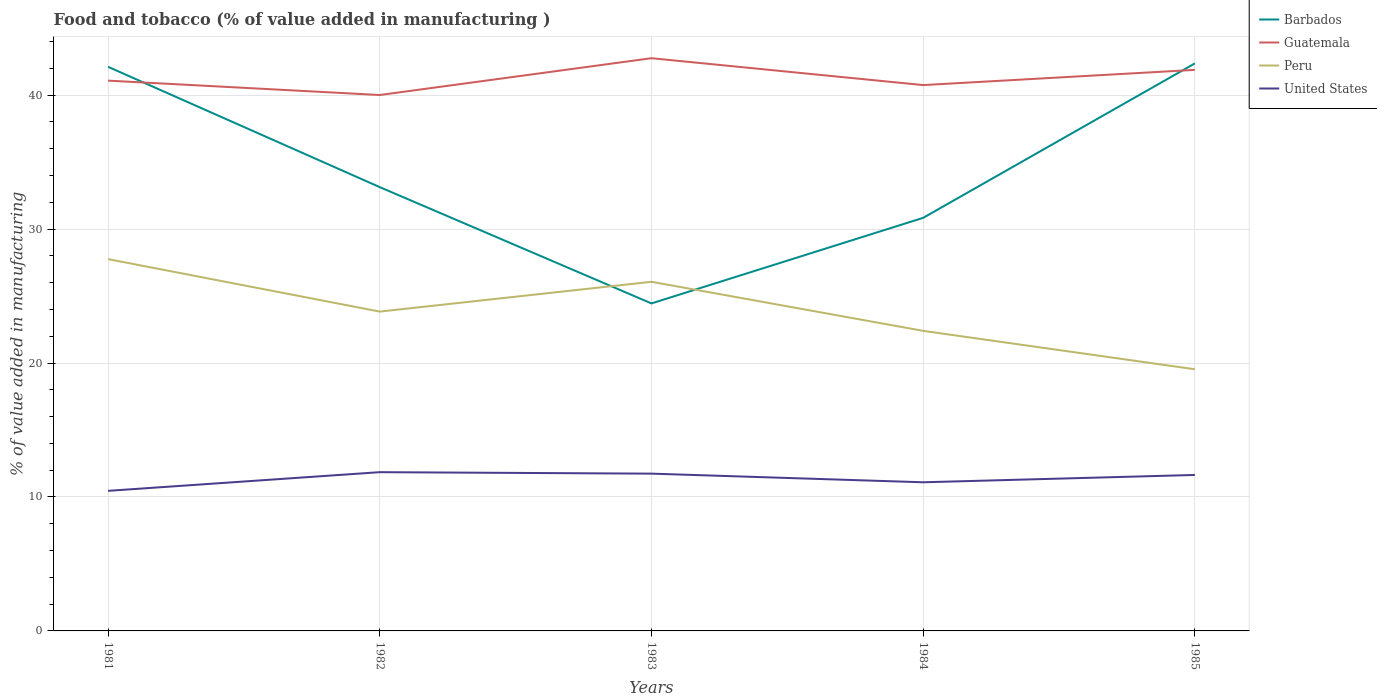Does the line corresponding to Peru intersect with the line corresponding to Barbados?
Provide a succinct answer. Yes. Across all years, what is the maximum value added in manufacturing food and tobacco in United States?
Your answer should be compact. 10.46. What is the total value added in manufacturing food and tobacco in Barbados in the graph?
Give a very brief answer. 8.98. What is the difference between the highest and the second highest value added in manufacturing food and tobacco in Barbados?
Your answer should be compact. 17.92. What is the difference between the highest and the lowest value added in manufacturing food and tobacco in Guatemala?
Make the answer very short. 2. Is the value added in manufacturing food and tobacco in Peru strictly greater than the value added in manufacturing food and tobacco in Guatemala over the years?
Your answer should be compact. Yes. How many lines are there?
Offer a terse response. 4. How many years are there in the graph?
Make the answer very short. 5. Does the graph contain grids?
Your response must be concise. Yes. How many legend labels are there?
Keep it short and to the point. 4. What is the title of the graph?
Offer a terse response. Food and tobacco (% of value added in manufacturing ). What is the label or title of the X-axis?
Your answer should be compact. Years. What is the label or title of the Y-axis?
Make the answer very short. % of value added in manufacturing. What is the % of value added in manufacturing in Barbados in 1981?
Ensure brevity in your answer.  42.12. What is the % of value added in manufacturing of Guatemala in 1981?
Ensure brevity in your answer.  41.09. What is the % of value added in manufacturing in Peru in 1981?
Your answer should be compact. 27.76. What is the % of value added in manufacturing in United States in 1981?
Your answer should be very brief. 10.46. What is the % of value added in manufacturing of Barbados in 1982?
Keep it short and to the point. 33.13. What is the % of value added in manufacturing of Guatemala in 1982?
Your answer should be compact. 40.01. What is the % of value added in manufacturing in Peru in 1982?
Provide a short and direct response. 23.84. What is the % of value added in manufacturing of United States in 1982?
Offer a terse response. 11.85. What is the % of value added in manufacturing of Barbados in 1983?
Ensure brevity in your answer.  24.45. What is the % of value added in manufacturing in Guatemala in 1983?
Provide a short and direct response. 42.76. What is the % of value added in manufacturing of Peru in 1983?
Provide a short and direct response. 26.07. What is the % of value added in manufacturing of United States in 1983?
Make the answer very short. 11.74. What is the % of value added in manufacturing of Barbados in 1984?
Offer a terse response. 30.84. What is the % of value added in manufacturing of Guatemala in 1984?
Make the answer very short. 40.75. What is the % of value added in manufacturing in Peru in 1984?
Your answer should be compact. 22.4. What is the % of value added in manufacturing in United States in 1984?
Provide a succinct answer. 11.1. What is the % of value added in manufacturing of Barbados in 1985?
Provide a succinct answer. 42.37. What is the % of value added in manufacturing in Guatemala in 1985?
Offer a terse response. 41.89. What is the % of value added in manufacturing of Peru in 1985?
Provide a short and direct response. 19.54. What is the % of value added in manufacturing of United States in 1985?
Your answer should be very brief. 11.64. Across all years, what is the maximum % of value added in manufacturing of Barbados?
Keep it short and to the point. 42.37. Across all years, what is the maximum % of value added in manufacturing in Guatemala?
Make the answer very short. 42.76. Across all years, what is the maximum % of value added in manufacturing of Peru?
Keep it short and to the point. 27.76. Across all years, what is the maximum % of value added in manufacturing of United States?
Your answer should be very brief. 11.85. Across all years, what is the minimum % of value added in manufacturing of Barbados?
Ensure brevity in your answer.  24.45. Across all years, what is the minimum % of value added in manufacturing of Guatemala?
Ensure brevity in your answer.  40.01. Across all years, what is the minimum % of value added in manufacturing in Peru?
Give a very brief answer. 19.54. Across all years, what is the minimum % of value added in manufacturing of United States?
Keep it short and to the point. 10.46. What is the total % of value added in manufacturing in Barbados in the graph?
Make the answer very short. 172.91. What is the total % of value added in manufacturing in Guatemala in the graph?
Your answer should be very brief. 206.5. What is the total % of value added in manufacturing of Peru in the graph?
Offer a very short reply. 119.6. What is the total % of value added in manufacturing in United States in the graph?
Offer a very short reply. 56.79. What is the difference between the % of value added in manufacturing of Barbados in 1981 and that in 1982?
Your answer should be compact. 8.98. What is the difference between the % of value added in manufacturing in Guatemala in 1981 and that in 1982?
Keep it short and to the point. 1.07. What is the difference between the % of value added in manufacturing of Peru in 1981 and that in 1982?
Provide a short and direct response. 3.92. What is the difference between the % of value added in manufacturing of United States in 1981 and that in 1982?
Offer a terse response. -1.39. What is the difference between the % of value added in manufacturing of Barbados in 1981 and that in 1983?
Make the answer very short. 17.67. What is the difference between the % of value added in manufacturing in Guatemala in 1981 and that in 1983?
Give a very brief answer. -1.67. What is the difference between the % of value added in manufacturing of Peru in 1981 and that in 1983?
Offer a very short reply. 1.69. What is the difference between the % of value added in manufacturing in United States in 1981 and that in 1983?
Keep it short and to the point. -1.28. What is the difference between the % of value added in manufacturing in Barbados in 1981 and that in 1984?
Keep it short and to the point. 11.28. What is the difference between the % of value added in manufacturing in Guatemala in 1981 and that in 1984?
Provide a short and direct response. 0.33. What is the difference between the % of value added in manufacturing in Peru in 1981 and that in 1984?
Make the answer very short. 5.36. What is the difference between the % of value added in manufacturing in United States in 1981 and that in 1984?
Provide a succinct answer. -0.64. What is the difference between the % of value added in manufacturing in Barbados in 1981 and that in 1985?
Offer a terse response. -0.25. What is the difference between the % of value added in manufacturing in Guatemala in 1981 and that in 1985?
Provide a succinct answer. -0.8. What is the difference between the % of value added in manufacturing in Peru in 1981 and that in 1985?
Your answer should be very brief. 8.22. What is the difference between the % of value added in manufacturing in United States in 1981 and that in 1985?
Provide a short and direct response. -1.19. What is the difference between the % of value added in manufacturing in Barbados in 1982 and that in 1983?
Make the answer very short. 8.68. What is the difference between the % of value added in manufacturing in Guatemala in 1982 and that in 1983?
Your response must be concise. -2.75. What is the difference between the % of value added in manufacturing of Peru in 1982 and that in 1983?
Give a very brief answer. -2.22. What is the difference between the % of value added in manufacturing of United States in 1982 and that in 1983?
Provide a short and direct response. 0.11. What is the difference between the % of value added in manufacturing in Barbados in 1982 and that in 1984?
Your answer should be very brief. 2.29. What is the difference between the % of value added in manufacturing in Guatemala in 1982 and that in 1984?
Your response must be concise. -0.74. What is the difference between the % of value added in manufacturing of Peru in 1982 and that in 1984?
Ensure brevity in your answer.  1.44. What is the difference between the % of value added in manufacturing in United States in 1982 and that in 1984?
Provide a short and direct response. 0.75. What is the difference between the % of value added in manufacturing of Barbados in 1982 and that in 1985?
Your answer should be compact. -9.24. What is the difference between the % of value added in manufacturing in Guatemala in 1982 and that in 1985?
Your response must be concise. -1.88. What is the difference between the % of value added in manufacturing of Peru in 1982 and that in 1985?
Keep it short and to the point. 4.3. What is the difference between the % of value added in manufacturing of United States in 1982 and that in 1985?
Your response must be concise. 0.21. What is the difference between the % of value added in manufacturing in Barbados in 1983 and that in 1984?
Your response must be concise. -6.39. What is the difference between the % of value added in manufacturing of Guatemala in 1983 and that in 1984?
Give a very brief answer. 2.01. What is the difference between the % of value added in manufacturing in Peru in 1983 and that in 1984?
Offer a terse response. 3.66. What is the difference between the % of value added in manufacturing in United States in 1983 and that in 1984?
Make the answer very short. 0.65. What is the difference between the % of value added in manufacturing of Barbados in 1983 and that in 1985?
Give a very brief answer. -17.92. What is the difference between the % of value added in manufacturing of Guatemala in 1983 and that in 1985?
Provide a short and direct response. 0.87. What is the difference between the % of value added in manufacturing in Peru in 1983 and that in 1985?
Your response must be concise. 6.53. What is the difference between the % of value added in manufacturing in United States in 1983 and that in 1985?
Provide a short and direct response. 0.1. What is the difference between the % of value added in manufacturing in Barbados in 1984 and that in 1985?
Offer a terse response. -11.53. What is the difference between the % of value added in manufacturing in Guatemala in 1984 and that in 1985?
Make the answer very short. -1.14. What is the difference between the % of value added in manufacturing of Peru in 1984 and that in 1985?
Ensure brevity in your answer.  2.87. What is the difference between the % of value added in manufacturing of United States in 1984 and that in 1985?
Offer a terse response. -0.55. What is the difference between the % of value added in manufacturing in Barbados in 1981 and the % of value added in manufacturing in Guatemala in 1982?
Offer a very short reply. 2.11. What is the difference between the % of value added in manufacturing in Barbados in 1981 and the % of value added in manufacturing in Peru in 1982?
Keep it short and to the point. 18.28. What is the difference between the % of value added in manufacturing in Barbados in 1981 and the % of value added in manufacturing in United States in 1982?
Give a very brief answer. 30.27. What is the difference between the % of value added in manufacturing in Guatemala in 1981 and the % of value added in manufacturing in Peru in 1982?
Your answer should be very brief. 17.24. What is the difference between the % of value added in manufacturing of Guatemala in 1981 and the % of value added in manufacturing of United States in 1982?
Give a very brief answer. 29.23. What is the difference between the % of value added in manufacturing of Peru in 1981 and the % of value added in manufacturing of United States in 1982?
Your response must be concise. 15.91. What is the difference between the % of value added in manufacturing of Barbados in 1981 and the % of value added in manufacturing of Guatemala in 1983?
Keep it short and to the point. -0.64. What is the difference between the % of value added in manufacturing in Barbados in 1981 and the % of value added in manufacturing in Peru in 1983?
Your response must be concise. 16.05. What is the difference between the % of value added in manufacturing in Barbados in 1981 and the % of value added in manufacturing in United States in 1983?
Ensure brevity in your answer.  30.37. What is the difference between the % of value added in manufacturing of Guatemala in 1981 and the % of value added in manufacturing of Peru in 1983?
Your response must be concise. 15.02. What is the difference between the % of value added in manufacturing in Guatemala in 1981 and the % of value added in manufacturing in United States in 1983?
Ensure brevity in your answer.  29.34. What is the difference between the % of value added in manufacturing of Peru in 1981 and the % of value added in manufacturing of United States in 1983?
Provide a succinct answer. 16.02. What is the difference between the % of value added in manufacturing of Barbados in 1981 and the % of value added in manufacturing of Guatemala in 1984?
Make the answer very short. 1.36. What is the difference between the % of value added in manufacturing in Barbados in 1981 and the % of value added in manufacturing in Peru in 1984?
Ensure brevity in your answer.  19.71. What is the difference between the % of value added in manufacturing of Barbados in 1981 and the % of value added in manufacturing of United States in 1984?
Make the answer very short. 31.02. What is the difference between the % of value added in manufacturing of Guatemala in 1981 and the % of value added in manufacturing of Peru in 1984?
Your answer should be compact. 18.68. What is the difference between the % of value added in manufacturing of Guatemala in 1981 and the % of value added in manufacturing of United States in 1984?
Provide a short and direct response. 29.99. What is the difference between the % of value added in manufacturing of Peru in 1981 and the % of value added in manufacturing of United States in 1984?
Give a very brief answer. 16.66. What is the difference between the % of value added in manufacturing in Barbados in 1981 and the % of value added in manufacturing in Guatemala in 1985?
Offer a very short reply. 0.23. What is the difference between the % of value added in manufacturing of Barbados in 1981 and the % of value added in manufacturing of Peru in 1985?
Your response must be concise. 22.58. What is the difference between the % of value added in manufacturing of Barbados in 1981 and the % of value added in manufacturing of United States in 1985?
Keep it short and to the point. 30.47. What is the difference between the % of value added in manufacturing of Guatemala in 1981 and the % of value added in manufacturing of Peru in 1985?
Provide a succinct answer. 21.55. What is the difference between the % of value added in manufacturing of Guatemala in 1981 and the % of value added in manufacturing of United States in 1985?
Keep it short and to the point. 29.44. What is the difference between the % of value added in manufacturing of Peru in 1981 and the % of value added in manufacturing of United States in 1985?
Provide a short and direct response. 16.11. What is the difference between the % of value added in manufacturing of Barbados in 1982 and the % of value added in manufacturing of Guatemala in 1983?
Keep it short and to the point. -9.63. What is the difference between the % of value added in manufacturing in Barbados in 1982 and the % of value added in manufacturing in Peru in 1983?
Provide a short and direct response. 7.07. What is the difference between the % of value added in manufacturing in Barbados in 1982 and the % of value added in manufacturing in United States in 1983?
Your answer should be compact. 21.39. What is the difference between the % of value added in manufacturing of Guatemala in 1982 and the % of value added in manufacturing of Peru in 1983?
Your answer should be very brief. 13.95. What is the difference between the % of value added in manufacturing in Guatemala in 1982 and the % of value added in manufacturing in United States in 1983?
Your answer should be very brief. 28.27. What is the difference between the % of value added in manufacturing of Peru in 1982 and the % of value added in manufacturing of United States in 1983?
Ensure brevity in your answer.  12.1. What is the difference between the % of value added in manufacturing of Barbados in 1982 and the % of value added in manufacturing of Guatemala in 1984?
Offer a very short reply. -7.62. What is the difference between the % of value added in manufacturing in Barbados in 1982 and the % of value added in manufacturing in Peru in 1984?
Keep it short and to the point. 10.73. What is the difference between the % of value added in manufacturing of Barbados in 1982 and the % of value added in manufacturing of United States in 1984?
Your answer should be compact. 22.04. What is the difference between the % of value added in manufacturing of Guatemala in 1982 and the % of value added in manufacturing of Peru in 1984?
Offer a terse response. 17.61. What is the difference between the % of value added in manufacturing of Guatemala in 1982 and the % of value added in manufacturing of United States in 1984?
Keep it short and to the point. 28.91. What is the difference between the % of value added in manufacturing of Peru in 1982 and the % of value added in manufacturing of United States in 1984?
Provide a succinct answer. 12.74. What is the difference between the % of value added in manufacturing of Barbados in 1982 and the % of value added in manufacturing of Guatemala in 1985?
Offer a very short reply. -8.76. What is the difference between the % of value added in manufacturing in Barbados in 1982 and the % of value added in manufacturing in Peru in 1985?
Ensure brevity in your answer.  13.6. What is the difference between the % of value added in manufacturing in Barbados in 1982 and the % of value added in manufacturing in United States in 1985?
Give a very brief answer. 21.49. What is the difference between the % of value added in manufacturing in Guatemala in 1982 and the % of value added in manufacturing in Peru in 1985?
Offer a terse response. 20.48. What is the difference between the % of value added in manufacturing in Guatemala in 1982 and the % of value added in manufacturing in United States in 1985?
Ensure brevity in your answer.  28.37. What is the difference between the % of value added in manufacturing of Peru in 1982 and the % of value added in manufacturing of United States in 1985?
Offer a terse response. 12.2. What is the difference between the % of value added in manufacturing in Barbados in 1983 and the % of value added in manufacturing in Guatemala in 1984?
Offer a very short reply. -16.3. What is the difference between the % of value added in manufacturing in Barbados in 1983 and the % of value added in manufacturing in Peru in 1984?
Provide a succinct answer. 2.05. What is the difference between the % of value added in manufacturing of Barbados in 1983 and the % of value added in manufacturing of United States in 1984?
Give a very brief answer. 13.35. What is the difference between the % of value added in manufacturing of Guatemala in 1983 and the % of value added in manufacturing of Peru in 1984?
Your response must be concise. 20.36. What is the difference between the % of value added in manufacturing in Guatemala in 1983 and the % of value added in manufacturing in United States in 1984?
Your answer should be very brief. 31.66. What is the difference between the % of value added in manufacturing of Peru in 1983 and the % of value added in manufacturing of United States in 1984?
Offer a terse response. 14.97. What is the difference between the % of value added in manufacturing in Barbados in 1983 and the % of value added in manufacturing in Guatemala in 1985?
Ensure brevity in your answer.  -17.44. What is the difference between the % of value added in manufacturing in Barbados in 1983 and the % of value added in manufacturing in Peru in 1985?
Offer a very short reply. 4.91. What is the difference between the % of value added in manufacturing in Barbados in 1983 and the % of value added in manufacturing in United States in 1985?
Your answer should be very brief. 12.81. What is the difference between the % of value added in manufacturing in Guatemala in 1983 and the % of value added in manufacturing in Peru in 1985?
Offer a very short reply. 23.22. What is the difference between the % of value added in manufacturing in Guatemala in 1983 and the % of value added in manufacturing in United States in 1985?
Give a very brief answer. 31.11. What is the difference between the % of value added in manufacturing in Peru in 1983 and the % of value added in manufacturing in United States in 1985?
Keep it short and to the point. 14.42. What is the difference between the % of value added in manufacturing of Barbados in 1984 and the % of value added in manufacturing of Guatemala in 1985?
Provide a short and direct response. -11.05. What is the difference between the % of value added in manufacturing of Barbados in 1984 and the % of value added in manufacturing of Peru in 1985?
Make the answer very short. 11.3. What is the difference between the % of value added in manufacturing in Barbados in 1984 and the % of value added in manufacturing in United States in 1985?
Offer a terse response. 19.2. What is the difference between the % of value added in manufacturing in Guatemala in 1984 and the % of value added in manufacturing in Peru in 1985?
Your answer should be very brief. 21.22. What is the difference between the % of value added in manufacturing in Guatemala in 1984 and the % of value added in manufacturing in United States in 1985?
Your answer should be very brief. 29.11. What is the difference between the % of value added in manufacturing of Peru in 1984 and the % of value added in manufacturing of United States in 1985?
Your answer should be compact. 10.76. What is the average % of value added in manufacturing in Barbados per year?
Make the answer very short. 34.58. What is the average % of value added in manufacturing of Guatemala per year?
Your answer should be compact. 41.3. What is the average % of value added in manufacturing in Peru per year?
Offer a very short reply. 23.92. What is the average % of value added in manufacturing of United States per year?
Provide a succinct answer. 11.36. In the year 1981, what is the difference between the % of value added in manufacturing in Barbados and % of value added in manufacturing in Guatemala?
Offer a terse response. 1.03. In the year 1981, what is the difference between the % of value added in manufacturing of Barbados and % of value added in manufacturing of Peru?
Your answer should be compact. 14.36. In the year 1981, what is the difference between the % of value added in manufacturing in Barbados and % of value added in manufacturing in United States?
Your answer should be compact. 31.66. In the year 1981, what is the difference between the % of value added in manufacturing in Guatemala and % of value added in manufacturing in Peru?
Provide a succinct answer. 13.33. In the year 1981, what is the difference between the % of value added in manufacturing of Guatemala and % of value added in manufacturing of United States?
Offer a very short reply. 30.63. In the year 1981, what is the difference between the % of value added in manufacturing of Peru and % of value added in manufacturing of United States?
Your answer should be very brief. 17.3. In the year 1982, what is the difference between the % of value added in manufacturing in Barbados and % of value added in manufacturing in Guatemala?
Provide a short and direct response. -6.88. In the year 1982, what is the difference between the % of value added in manufacturing of Barbados and % of value added in manufacturing of Peru?
Offer a very short reply. 9.29. In the year 1982, what is the difference between the % of value added in manufacturing in Barbados and % of value added in manufacturing in United States?
Your response must be concise. 21.28. In the year 1982, what is the difference between the % of value added in manufacturing in Guatemala and % of value added in manufacturing in Peru?
Ensure brevity in your answer.  16.17. In the year 1982, what is the difference between the % of value added in manufacturing of Guatemala and % of value added in manufacturing of United States?
Offer a terse response. 28.16. In the year 1982, what is the difference between the % of value added in manufacturing of Peru and % of value added in manufacturing of United States?
Offer a very short reply. 11.99. In the year 1983, what is the difference between the % of value added in manufacturing in Barbados and % of value added in manufacturing in Guatemala?
Ensure brevity in your answer.  -18.31. In the year 1983, what is the difference between the % of value added in manufacturing in Barbados and % of value added in manufacturing in Peru?
Your answer should be very brief. -1.62. In the year 1983, what is the difference between the % of value added in manufacturing of Barbados and % of value added in manufacturing of United States?
Offer a terse response. 12.71. In the year 1983, what is the difference between the % of value added in manufacturing of Guatemala and % of value added in manufacturing of Peru?
Your answer should be compact. 16.69. In the year 1983, what is the difference between the % of value added in manufacturing in Guatemala and % of value added in manufacturing in United States?
Give a very brief answer. 31.02. In the year 1983, what is the difference between the % of value added in manufacturing of Peru and % of value added in manufacturing of United States?
Your response must be concise. 14.32. In the year 1984, what is the difference between the % of value added in manufacturing in Barbados and % of value added in manufacturing in Guatemala?
Your response must be concise. -9.91. In the year 1984, what is the difference between the % of value added in manufacturing in Barbados and % of value added in manufacturing in Peru?
Give a very brief answer. 8.44. In the year 1984, what is the difference between the % of value added in manufacturing of Barbados and % of value added in manufacturing of United States?
Offer a very short reply. 19.74. In the year 1984, what is the difference between the % of value added in manufacturing in Guatemala and % of value added in manufacturing in Peru?
Offer a very short reply. 18.35. In the year 1984, what is the difference between the % of value added in manufacturing in Guatemala and % of value added in manufacturing in United States?
Ensure brevity in your answer.  29.66. In the year 1984, what is the difference between the % of value added in manufacturing of Peru and % of value added in manufacturing of United States?
Offer a terse response. 11.31. In the year 1985, what is the difference between the % of value added in manufacturing of Barbados and % of value added in manufacturing of Guatemala?
Make the answer very short. 0.48. In the year 1985, what is the difference between the % of value added in manufacturing of Barbados and % of value added in manufacturing of Peru?
Make the answer very short. 22.84. In the year 1985, what is the difference between the % of value added in manufacturing of Barbados and % of value added in manufacturing of United States?
Give a very brief answer. 30.73. In the year 1985, what is the difference between the % of value added in manufacturing in Guatemala and % of value added in manufacturing in Peru?
Offer a terse response. 22.35. In the year 1985, what is the difference between the % of value added in manufacturing in Guatemala and % of value added in manufacturing in United States?
Give a very brief answer. 30.24. In the year 1985, what is the difference between the % of value added in manufacturing of Peru and % of value added in manufacturing of United States?
Make the answer very short. 7.89. What is the ratio of the % of value added in manufacturing of Barbados in 1981 to that in 1982?
Provide a succinct answer. 1.27. What is the ratio of the % of value added in manufacturing in Guatemala in 1981 to that in 1982?
Ensure brevity in your answer.  1.03. What is the ratio of the % of value added in manufacturing of Peru in 1981 to that in 1982?
Provide a succinct answer. 1.16. What is the ratio of the % of value added in manufacturing in United States in 1981 to that in 1982?
Your response must be concise. 0.88. What is the ratio of the % of value added in manufacturing of Barbados in 1981 to that in 1983?
Offer a very short reply. 1.72. What is the ratio of the % of value added in manufacturing in Guatemala in 1981 to that in 1983?
Ensure brevity in your answer.  0.96. What is the ratio of the % of value added in manufacturing in Peru in 1981 to that in 1983?
Provide a succinct answer. 1.06. What is the ratio of the % of value added in manufacturing of United States in 1981 to that in 1983?
Offer a very short reply. 0.89. What is the ratio of the % of value added in manufacturing in Barbados in 1981 to that in 1984?
Your response must be concise. 1.37. What is the ratio of the % of value added in manufacturing in Guatemala in 1981 to that in 1984?
Offer a very short reply. 1.01. What is the ratio of the % of value added in manufacturing in Peru in 1981 to that in 1984?
Offer a very short reply. 1.24. What is the ratio of the % of value added in manufacturing of United States in 1981 to that in 1984?
Provide a succinct answer. 0.94. What is the ratio of the % of value added in manufacturing of Barbados in 1981 to that in 1985?
Your response must be concise. 0.99. What is the ratio of the % of value added in manufacturing in Guatemala in 1981 to that in 1985?
Make the answer very short. 0.98. What is the ratio of the % of value added in manufacturing in Peru in 1981 to that in 1985?
Ensure brevity in your answer.  1.42. What is the ratio of the % of value added in manufacturing in United States in 1981 to that in 1985?
Make the answer very short. 0.9. What is the ratio of the % of value added in manufacturing in Barbados in 1982 to that in 1983?
Give a very brief answer. 1.36. What is the ratio of the % of value added in manufacturing in Guatemala in 1982 to that in 1983?
Your answer should be very brief. 0.94. What is the ratio of the % of value added in manufacturing in Peru in 1982 to that in 1983?
Your answer should be very brief. 0.91. What is the ratio of the % of value added in manufacturing in United States in 1982 to that in 1983?
Provide a succinct answer. 1.01. What is the ratio of the % of value added in manufacturing in Barbados in 1982 to that in 1984?
Offer a very short reply. 1.07. What is the ratio of the % of value added in manufacturing of Guatemala in 1982 to that in 1984?
Keep it short and to the point. 0.98. What is the ratio of the % of value added in manufacturing of Peru in 1982 to that in 1984?
Your answer should be compact. 1.06. What is the ratio of the % of value added in manufacturing of United States in 1982 to that in 1984?
Your answer should be compact. 1.07. What is the ratio of the % of value added in manufacturing of Barbados in 1982 to that in 1985?
Your response must be concise. 0.78. What is the ratio of the % of value added in manufacturing in Guatemala in 1982 to that in 1985?
Your response must be concise. 0.96. What is the ratio of the % of value added in manufacturing of Peru in 1982 to that in 1985?
Make the answer very short. 1.22. What is the ratio of the % of value added in manufacturing of United States in 1982 to that in 1985?
Provide a short and direct response. 1.02. What is the ratio of the % of value added in manufacturing in Barbados in 1983 to that in 1984?
Provide a short and direct response. 0.79. What is the ratio of the % of value added in manufacturing of Guatemala in 1983 to that in 1984?
Provide a succinct answer. 1.05. What is the ratio of the % of value added in manufacturing of Peru in 1983 to that in 1984?
Offer a terse response. 1.16. What is the ratio of the % of value added in manufacturing of United States in 1983 to that in 1984?
Keep it short and to the point. 1.06. What is the ratio of the % of value added in manufacturing of Barbados in 1983 to that in 1985?
Your response must be concise. 0.58. What is the ratio of the % of value added in manufacturing of Guatemala in 1983 to that in 1985?
Make the answer very short. 1.02. What is the ratio of the % of value added in manufacturing in Peru in 1983 to that in 1985?
Offer a very short reply. 1.33. What is the ratio of the % of value added in manufacturing of United States in 1983 to that in 1985?
Offer a very short reply. 1.01. What is the ratio of the % of value added in manufacturing in Barbados in 1984 to that in 1985?
Provide a short and direct response. 0.73. What is the ratio of the % of value added in manufacturing in Guatemala in 1984 to that in 1985?
Give a very brief answer. 0.97. What is the ratio of the % of value added in manufacturing of Peru in 1984 to that in 1985?
Keep it short and to the point. 1.15. What is the ratio of the % of value added in manufacturing in United States in 1984 to that in 1985?
Make the answer very short. 0.95. What is the difference between the highest and the second highest % of value added in manufacturing of Barbados?
Offer a terse response. 0.25. What is the difference between the highest and the second highest % of value added in manufacturing of Guatemala?
Keep it short and to the point. 0.87. What is the difference between the highest and the second highest % of value added in manufacturing in Peru?
Ensure brevity in your answer.  1.69. What is the difference between the highest and the second highest % of value added in manufacturing in United States?
Ensure brevity in your answer.  0.11. What is the difference between the highest and the lowest % of value added in manufacturing of Barbados?
Your answer should be very brief. 17.92. What is the difference between the highest and the lowest % of value added in manufacturing in Guatemala?
Keep it short and to the point. 2.75. What is the difference between the highest and the lowest % of value added in manufacturing in Peru?
Make the answer very short. 8.22. What is the difference between the highest and the lowest % of value added in manufacturing of United States?
Ensure brevity in your answer.  1.39. 